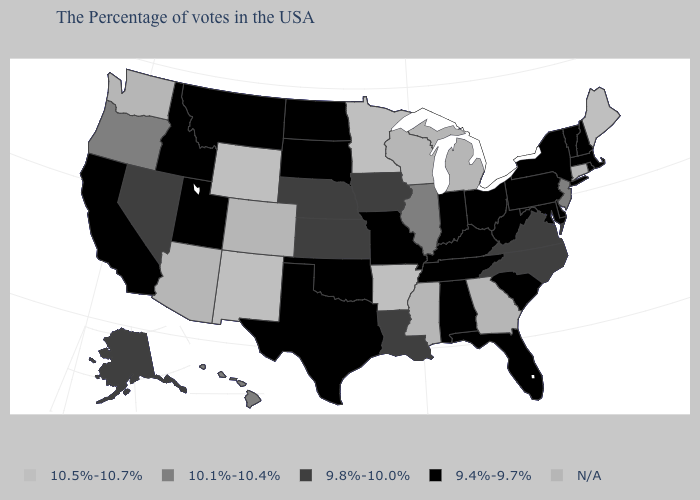Which states hav the highest value in the West?
Keep it brief. Wyoming, New Mexico. What is the lowest value in the USA?
Answer briefly. 9.4%-9.7%. How many symbols are there in the legend?
Be succinct. 5. Does the map have missing data?
Answer briefly. Yes. Does the map have missing data?
Answer briefly. Yes. Does Maine have the highest value in the USA?
Write a very short answer. Yes. What is the value of Florida?
Short answer required. 9.4%-9.7%. What is the value of North Dakota?
Be succinct. 9.4%-9.7%. Among the states that border Oklahoma , which have the highest value?
Write a very short answer. Arkansas, New Mexico. Among the states that border Nebraska , does Kansas have the lowest value?
Answer briefly. No. Which states have the lowest value in the Northeast?
Answer briefly. Massachusetts, Rhode Island, New Hampshire, Vermont, New York, Pennsylvania. Which states hav the highest value in the South?
Write a very short answer. Arkansas. Name the states that have a value in the range 10.5%-10.7%?
Give a very brief answer. Maine, Arkansas, Minnesota, Wyoming, New Mexico. 